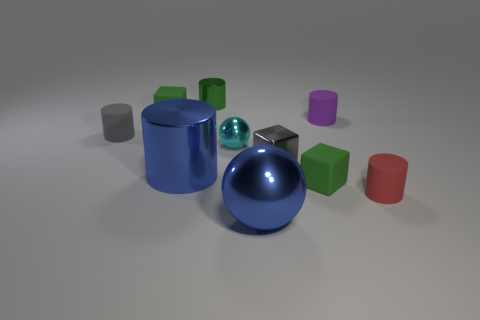Which of the objects in this image reflect light the most? The objects with the shiniest surfaces, notably the blue sphere in the center and the smaller blue sphere, reflect light the most, giving off a distinctive glossy appearance. 